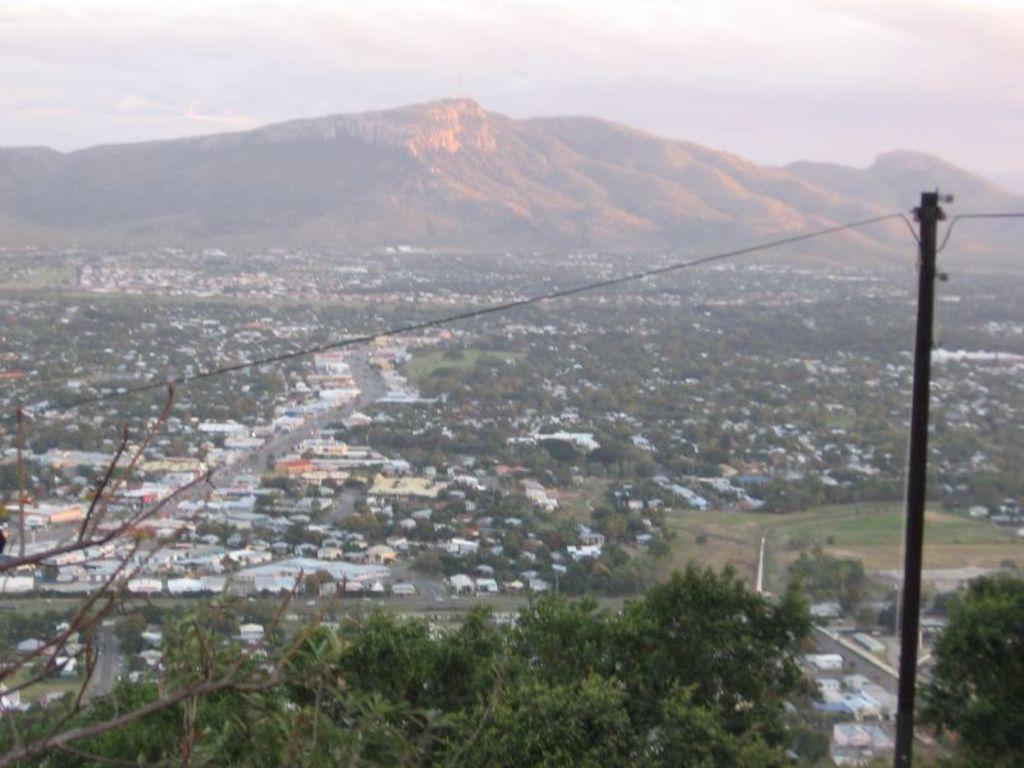Please provide a concise description of this image. On the right side, there is a pole having a cable. In the background, there are buildings, trees and mountains on the ground and there are clouds in the sky. 